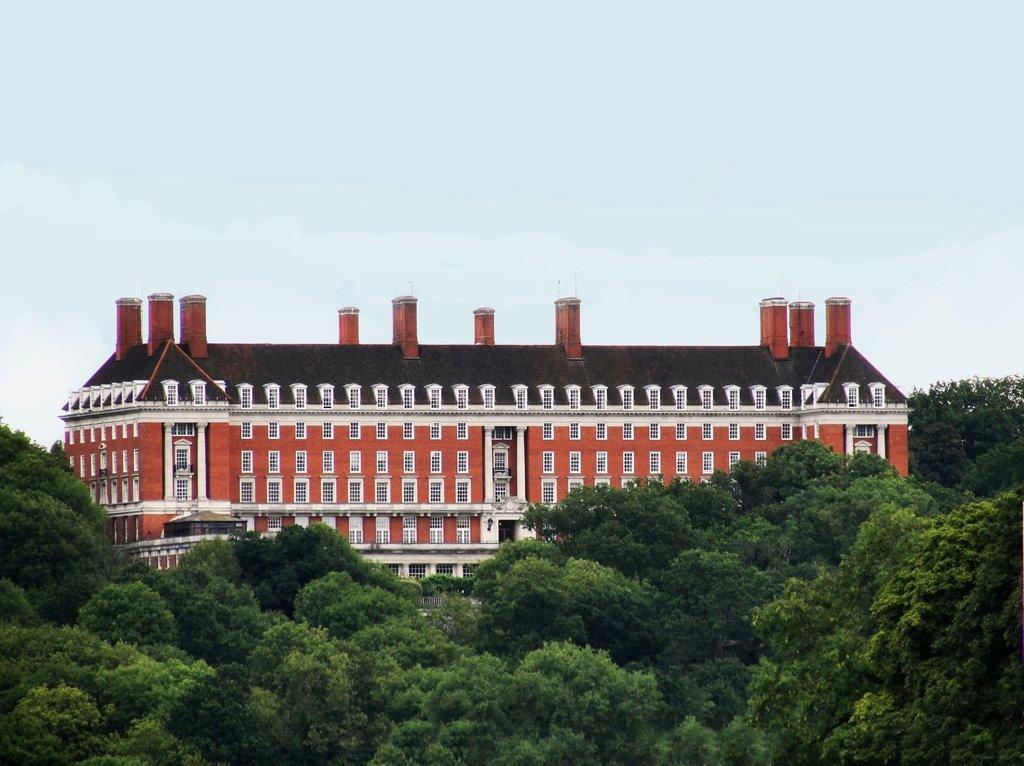What type of natural elements can be seen in the image? There are trees in the image. What type of structure is present in the image? There is a building with many windows in the image. What architectural features can be observed on the building? The building has pillars. What is visible in the background of the image? The sky in the background is plain. Can you hear the drum being played in the image? There is no drum or sound present in the image, so it is not possible to hear any drumming. 